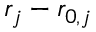<formula> <loc_0><loc_0><loc_500><loc_500>r _ { j } - r _ { 0 , j }</formula> 